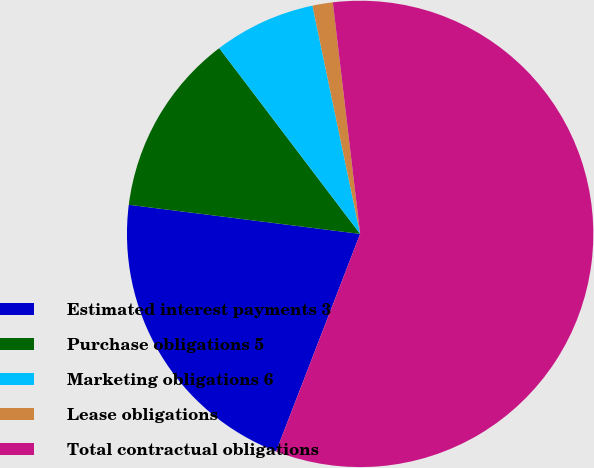<chart> <loc_0><loc_0><loc_500><loc_500><pie_chart><fcel>Estimated interest payments 3<fcel>Purchase obligations 5<fcel>Marketing obligations 6<fcel>Lease obligations<fcel>Total contractual obligations<nl><fcel>21.13%<fcel>12.68%<fcel>7.05%<fcel>1.41%<fcel>57.74%<nl></chart> 